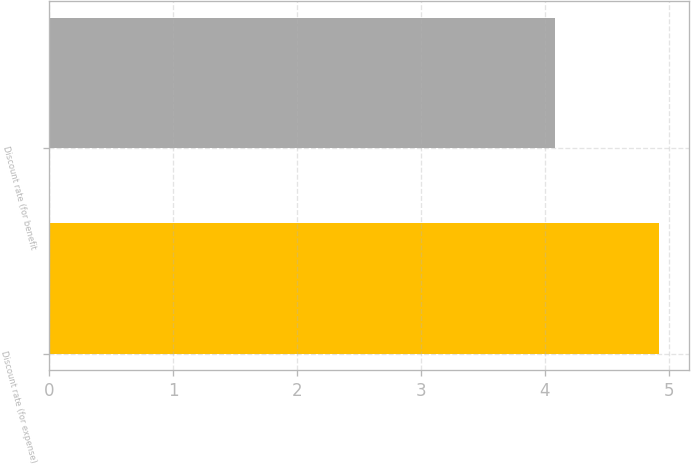<chart> <loc_0><loc_0><loc_500><loc_500><bar_chart><fcel>Discount rate (for expense)<fcel>Discount rate (for benefit<nl><fcel>4.92<fcel>4.08<nl></chart> 